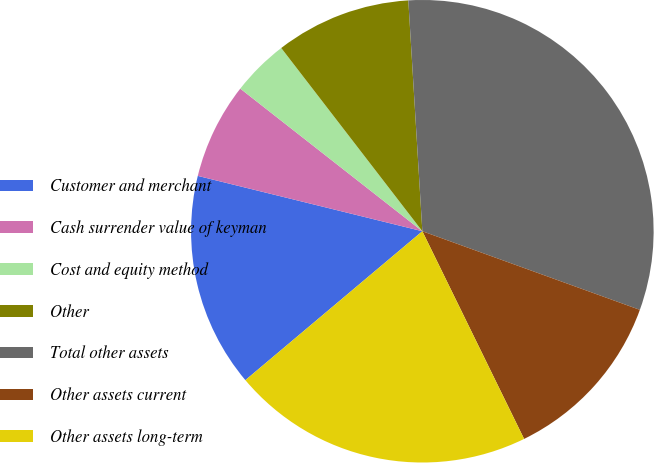Convert chart. <chart><loc_0><loc_0><loc_500><loc_500><pie_chart><fcel>Customer and merchant<fcel>Cash surrender value of keyman<fcel>Cost and equity method<fcel>Other<fcel>Total other assets<fcel>Other assets current<fcel>Other assets long-term<nl><fcel>14.98%<fcel>6.73%<fcel>3.98%<fcel>9.48%<fcel>31.49%<fcel>12.23%<fcel>21.12%<nl></chart> 